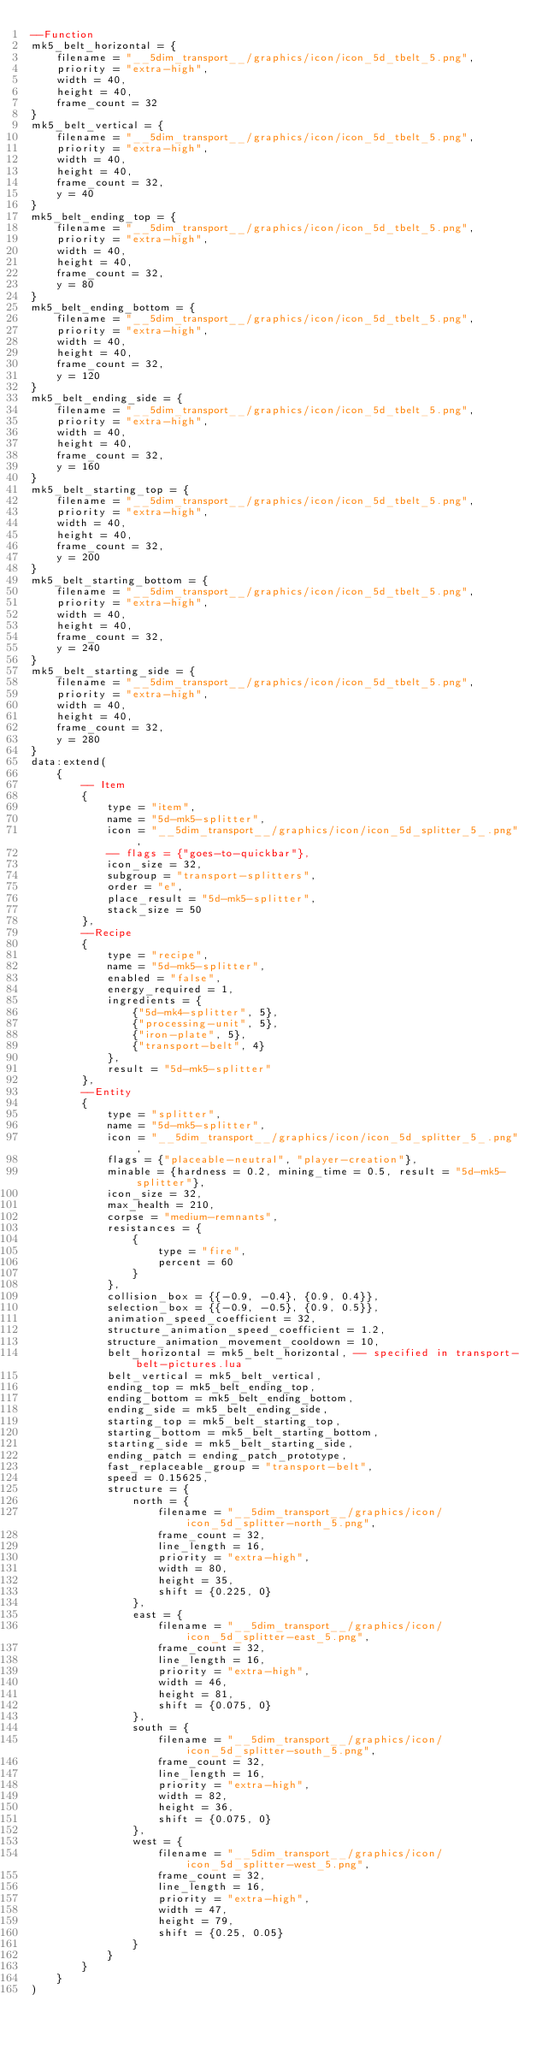Convert code to text. <code><loc_0><loc_0><loc_500><loc_500><_Lua_>--Function
mk5_belt_horizontal = {
    filename = "__5dim_transport__/graphics/icon/icon_5d_tbelt_5.png",
    priority = "extra-high",
    width = 40,
    height = 40,
    frame_count = 32
}
mk5_belt_vertical = {
    filename = "__5dim_transport__/graphics/icon/icon_5d_tbelt_5.png",
    priority = "extra-high",
    width = 40,
    height = 40,
    frame_count = 32,
    y = 40
}
mk5_belt_ending_top = {
    filename = "__5dim_transport__/graphics/icon/icon_5d_tbelt_5.png",
    priority = "extra-high",
    width = 40,
    height = 40,
    frame_count = 32,
    y = 80
}
mk5_belt_ending_bottom = {
    filename = "__5dim_transport__/graphics/icon/icon_5d_tbelt_5.png",
    priority = "extra-high",
    width = 40,
    height = 40,
    frame_count = 32,
    y = 120
}
mk5_belt_ending_side = {
    filename = "__5dim_transport__/graphics/icon/icon_5d_tbelt_5.png",
    priority = "extra-high",
    width = 40,
    height = 40,
    frame_count = 32,
    y = 160
}
mk5_belt_starting_top = {
    filename = "__5dim_transport__/graphics/icon/icon_5d_tbelt_5.png",
    priority = "extra-high",
    width = 40,
    height = 40,
    frame_count = 32,
    y = 200
}
mk5_belt_starting_bottom = {
    filename = "__5dim_transport__/graphics/icon/icon_5d_tbelt_5.png",
    priority = "extra-high",
    width = 40,
    height = 40,
    frame_count = 32,
    y = 240
}
mk5_belt_starting_side = {
    filename = "__5dim_transport__/graphics/icon/icon_5d_tbelt_5.png",
    priority = "extra-high",
    width = 40,
    height = 40,
    frame_count = 32,
    y = 280
}
data:extend(
    {
        -- Item
        {
            type = "item",
            name = "5d-mk5-splitter",
            icon = "__5dim_transport__/graphics/icon/icon_5d_splitter_5_.png",
            -- flags = {"goes-to-quickbar"},
            icon_size = 32,
            subgroup = "transport-splitters",
            order = "e",
            place_result = "5d-mk5-splitter",
            stack_size = 50
        },
        --Recipe
        {
            type = "recipe",
            name = "5d-mk5-splitter",
            enabled = "false",
            energy_required = 1,
            ingredients = {
                {"5d-mk4-splitter", 5},
                {"processing-unit", 5},
                {"iron-plate", 5},
                {"transport-belt", 4}
            },
            result = "5d-mk5-splitter"
        },
        --Entity
        {
            type = "splitter",
            name = "5d-mk5-splitter",
            icon = "__5dim_transport__/graphics/icon/icon_5d_splitter_5_.png",
            flags = {"placeable-neutral", "player-creation"},
            minable = {hardness = 0.2, mining_time = 0.5, result = "5d-mk5-splitter"},
            icon_size = 32,
            max_health = 210,
            corpse = "medium-remnants",
            resistances = {
                {
                    type = "fire",
                    percent = 60
                }
            },
            collision_box = {{-0.9, -0.4}, {0.9, 0.4}},
            selection_box = {{-0.9, -0.5}, {0.9, 0.5}},
            animation_speed_coefficient = 32,
            structure_animation_speed_coefficient = 1.2,
            structure_animation_movement_cooldown = 10,
            belt_horizontal = mk5_belt_horizontal, -- specified in transport-belt-pictures.lua
            belt_vertical = mk5_belt_vertical,
            ending_top = mk5_belt_ending_top,
            ending_bottom = mk5_belt_ending_bottom,
            ending_side = mk5_belt_ending_side,
            starting_top = mk5_belt_starting_top,
            starting_bottom = mk5_belt_starting_bottom,
            starting_side = mk5_belt_starting_side,
            ending_patch = ending_patch_prototype,
            fast_replaceable_group = "transport-belt",
            speed = 0.15625,
            structure = {
                north = {
                    filename = "__5dim_transport__/graphics/icon/icon_5d_splitter-north_5.png",
                    frame_count = 32,
                    line_length = 16,
                    priority = "extra-high",
                    width = 80,
                    height = 35,
                    shift = {0.225, 0}
                },
                east = {
                    filename = "__5dim_transport__/graphics/icon/icon_5d_splitter-east_5.png",
                    frame_count = 32,
                    line_length = 16,
                    priority = "extra-high",
                    width = 46,
                    height = 81,
                    shift = {0.075, 0}
                },
                south = {
                    filename = "__5dim_transport__/graphics/icon/icon_5d_splitter-south_5.png",
                    frame_count = 32,
                    line_length = 16,
                    priority = "extra-high",
                    width = 82,
                    height = 36,
                    shift = {0.075, 0}
                },
                west = {
                    filename = "__5dim_transport__/graphics/icon/icon_5d_splitter-west_5.png",
                    frame_count = 32,
                    line_length = 16,
                    priority = "extra-high",
                    width = 47,
                    height = 79,
                    shift = {0.25, 0.05}
                }
            }
        }
    }
)
</code> 